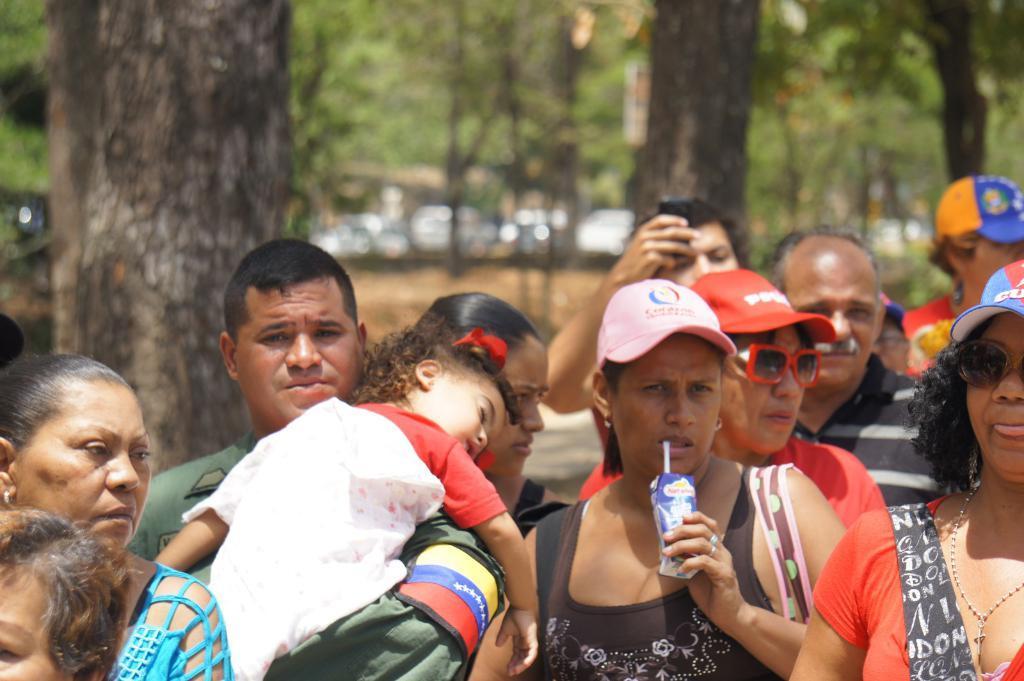In one or two sentences, can you explain what this image depicts? Here we can see few persons. In the background we can see trees and vehicles. 